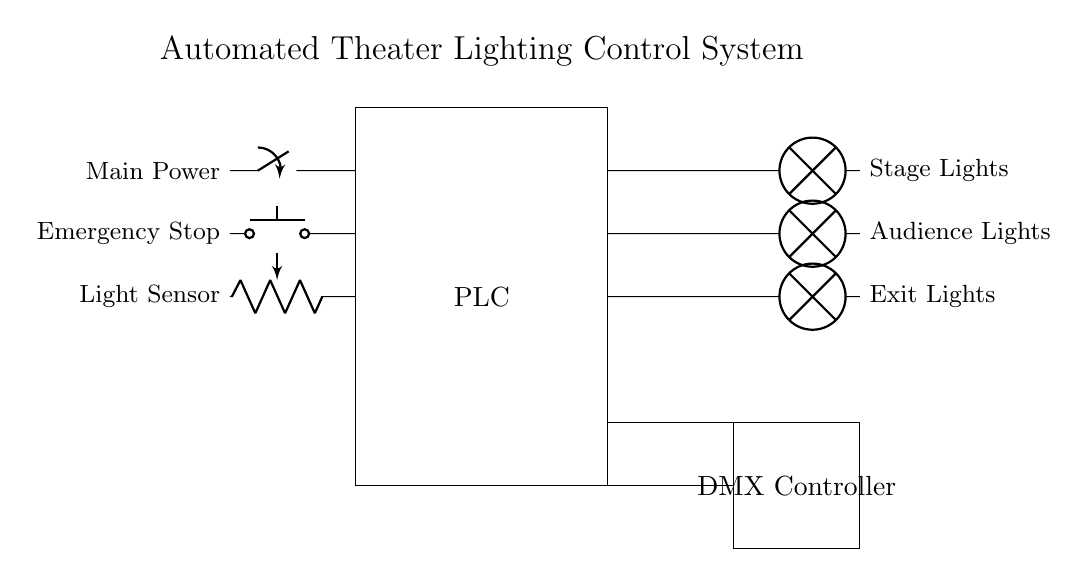What is the main component of the system? The main component is the PLC, which stands for Programmable Logic Controller. It is depicted as a rectangular box in the circuit diagram.
Answer: PLC How many types of lights are controlled? There are three types of lights: Stage Lights, Audience Lights, and Exit Lights, each represented as a separate lamp in the diagram.
Answer: Three What is the purpose of the light sensor in the circuit? The light sensor provides feedback to the PLC about the ambient light conditions, allowing the system to adjust the lighting accordingly. Its role is to measure light levels to enable automation.
Answer: Feedback What action does the emergency stop switch perform? The emergency stop switch is a safety feature that, when activated, immediately cuts power to the system, stopping all lighting outputs to ensure safety.
Answer: Cut power Which component communicates with the DMX controller? The PLC communicates with the DMX controller, which allows for the control of various lighting channels and effects beyond the automated system in place.
Answer: PLC What does the main power switch control? The main power switch controls the overall power supply to the PLC and the entire lighting system, allowing it to be turned on or off as needed.
Answer: Overall power 